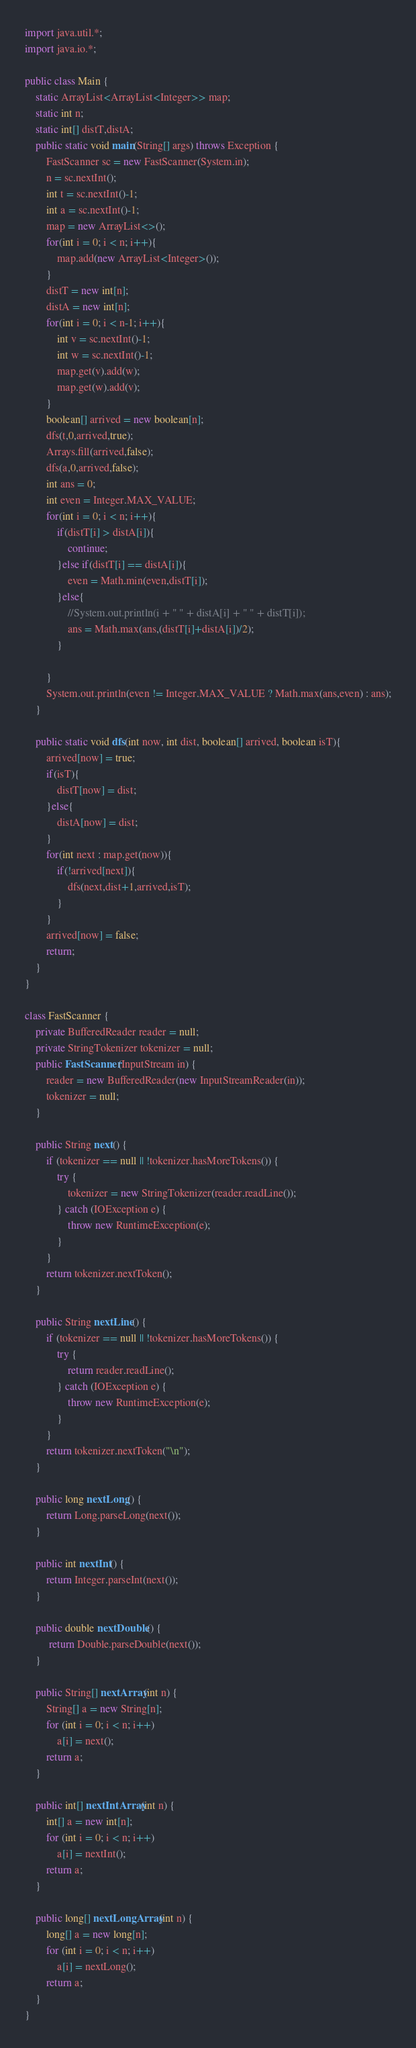Convert code to text. <code><loc_0><loc_0><loc_500><loc_500><_Java_>import java.util.*;
import java.io.*;
 
public class Main {
    static ArrayList<ArrayList<Integer>> map;
    static int n;
    static int[] distT,distA;
    public static void main(String[] args) throws Exception {
        FastScanner sc = new FastScanner(System.in);
        n = sc.nextInt();
        int t = sc.nextInt()-1;
        int a = sc.nextInt()-1;
        map = new ArrayList<>();
        for(int i = 0; i < n; i++){
            map.add(new ArrayList<Integer>());
        }
        distT = new int[n];
        distA = new int[n];
        for(int i = 0; i < n-1; i++){
            int v = sc.nextInt()-1;
            int w = sc.nextInt()-1;
            map.get(v).add(w);
            map.get(w).add(v);
        }
        boolean[] arrived = new boolean[n]; 
        dfs(t,0,arrived,true);
        Arrays.fill(arrived,false);
        dfs(a,0,arrived,false);
        int ans = 0;
        int even = Integer.MAX_VALUE;
        for(int i = 0; i < n; i++){
            if(distT[i] > distA[i]){
                continue;
            }else if(distT[i] == distA[i]){
                even = Math.min(even,distT[i]);
            }else{
                //System.out.println(i + " " + distA[i] + " " + distT[i]);
                ans = Math.max(ans,(distT[i]+distA[i])/2);
            }
            
        }
        System.out.println(even != Integer.MAX_VALUE ? Math.max(ans,even) : ans);
    }
    
    public static void dfs(int now, int dist, boolean[] arrived, boolean isT){
        arrived[now] = true;
        if(isT){
            distT[now] = dist;
        }else{
            distA[now] = dist;
        }
        for(int next : map.get(now)){
            if(!arrived[next]){
                dfs(next,dist+1,arrived,isT);
            }
        }
        arrived[now] = false;
        return;
    }
}

class FastScanner {
    private BufferedReader reader = null;
    private StringTokenizer tokenizer = null;
    public FastScanner(InputStream in) {
        reader = new BufferedReader(new InputStreamReader(in));
        tokenizer = null;
    }

    public String next() {
        if (tokenizer == null || !tokenizer.hasMoreTokens()) {
            try {
                tokenizer = new StringTokenizer(reader.readLine());
            } catch (IOException e) {
                throw new RuntimeException(e);
            }
        }
        return tokenizer.nextToken();
    }

    public String nextLine() {
        if (tokenizer == null || !tokenizer.hasMoreTokens()) {
            try {
                return reader.readLine();
            } catch (IOException e) {
                throw new RuntimeException(e);
            }
        }
        return tokenizer.nextToken("\n");
    }

    public long nextLong() {
        return Long.parseLong(next());
    }

    public int nextInt() {
        return Integer.parseInt(next());
    }

    public double nextDouble() {
         return Double.parseDouble(next());
    }
    
    public String[] nextArray(int n) {
        String[] a = new String[n];
        for (int i = 0; i < n; i++)
            a[i] = next();
        return a;
    }

    public int[] nextIntArray(int n) {
        int[] a = new int[n];
        for (int i = 0; i < n; i++)
            a[i] = nextInt();
        return a;
    }

    public long[] nextLongArray(int n) {
        long[] a = new long[n];
        for (int i = 0; i < n; i++)
            a[i] = nextLong();
        return a;
    } 
}
</code> 